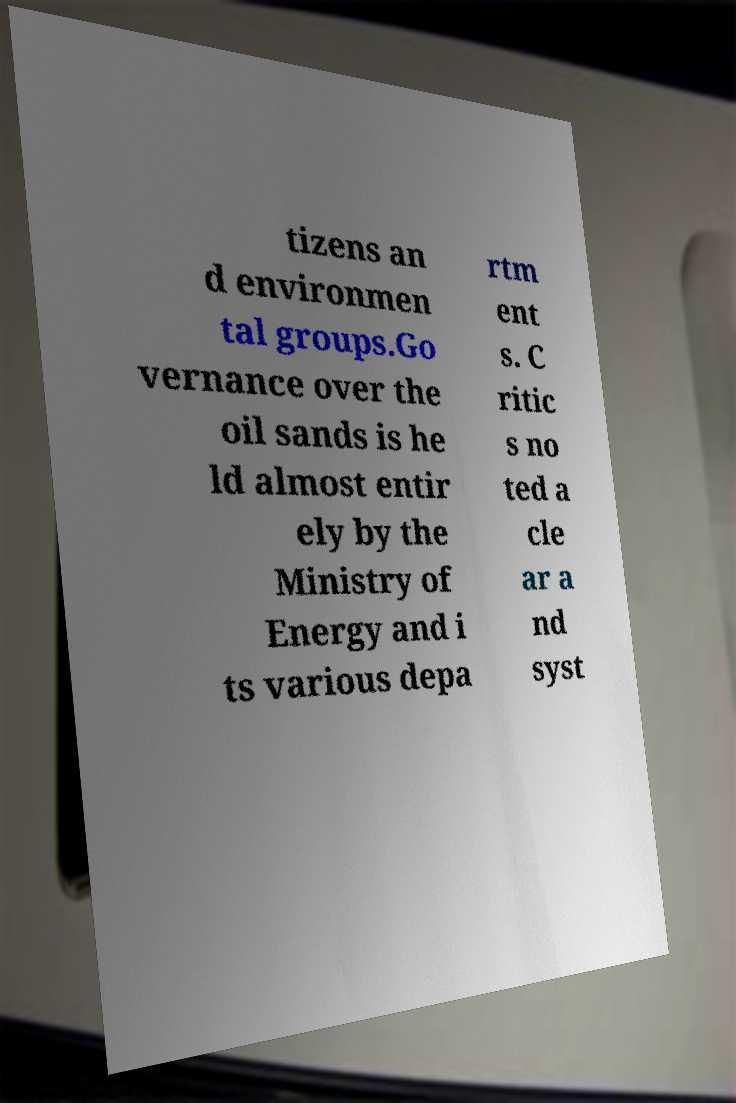There's text embedded in this image that I need extracted. Can you transcribe it verbatim? tizens an d environmen tal groups.Go vernance over the oil sands is he ld almost entir ely by the Ministry of Energy and i ts various depa rtm ent s. C ritic s no ted a cle ar a nd syst 